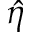Convert formula to latex. <formula><loc_0><loc_0><loc_500><loc_500>\hat { \eta }</formula> 